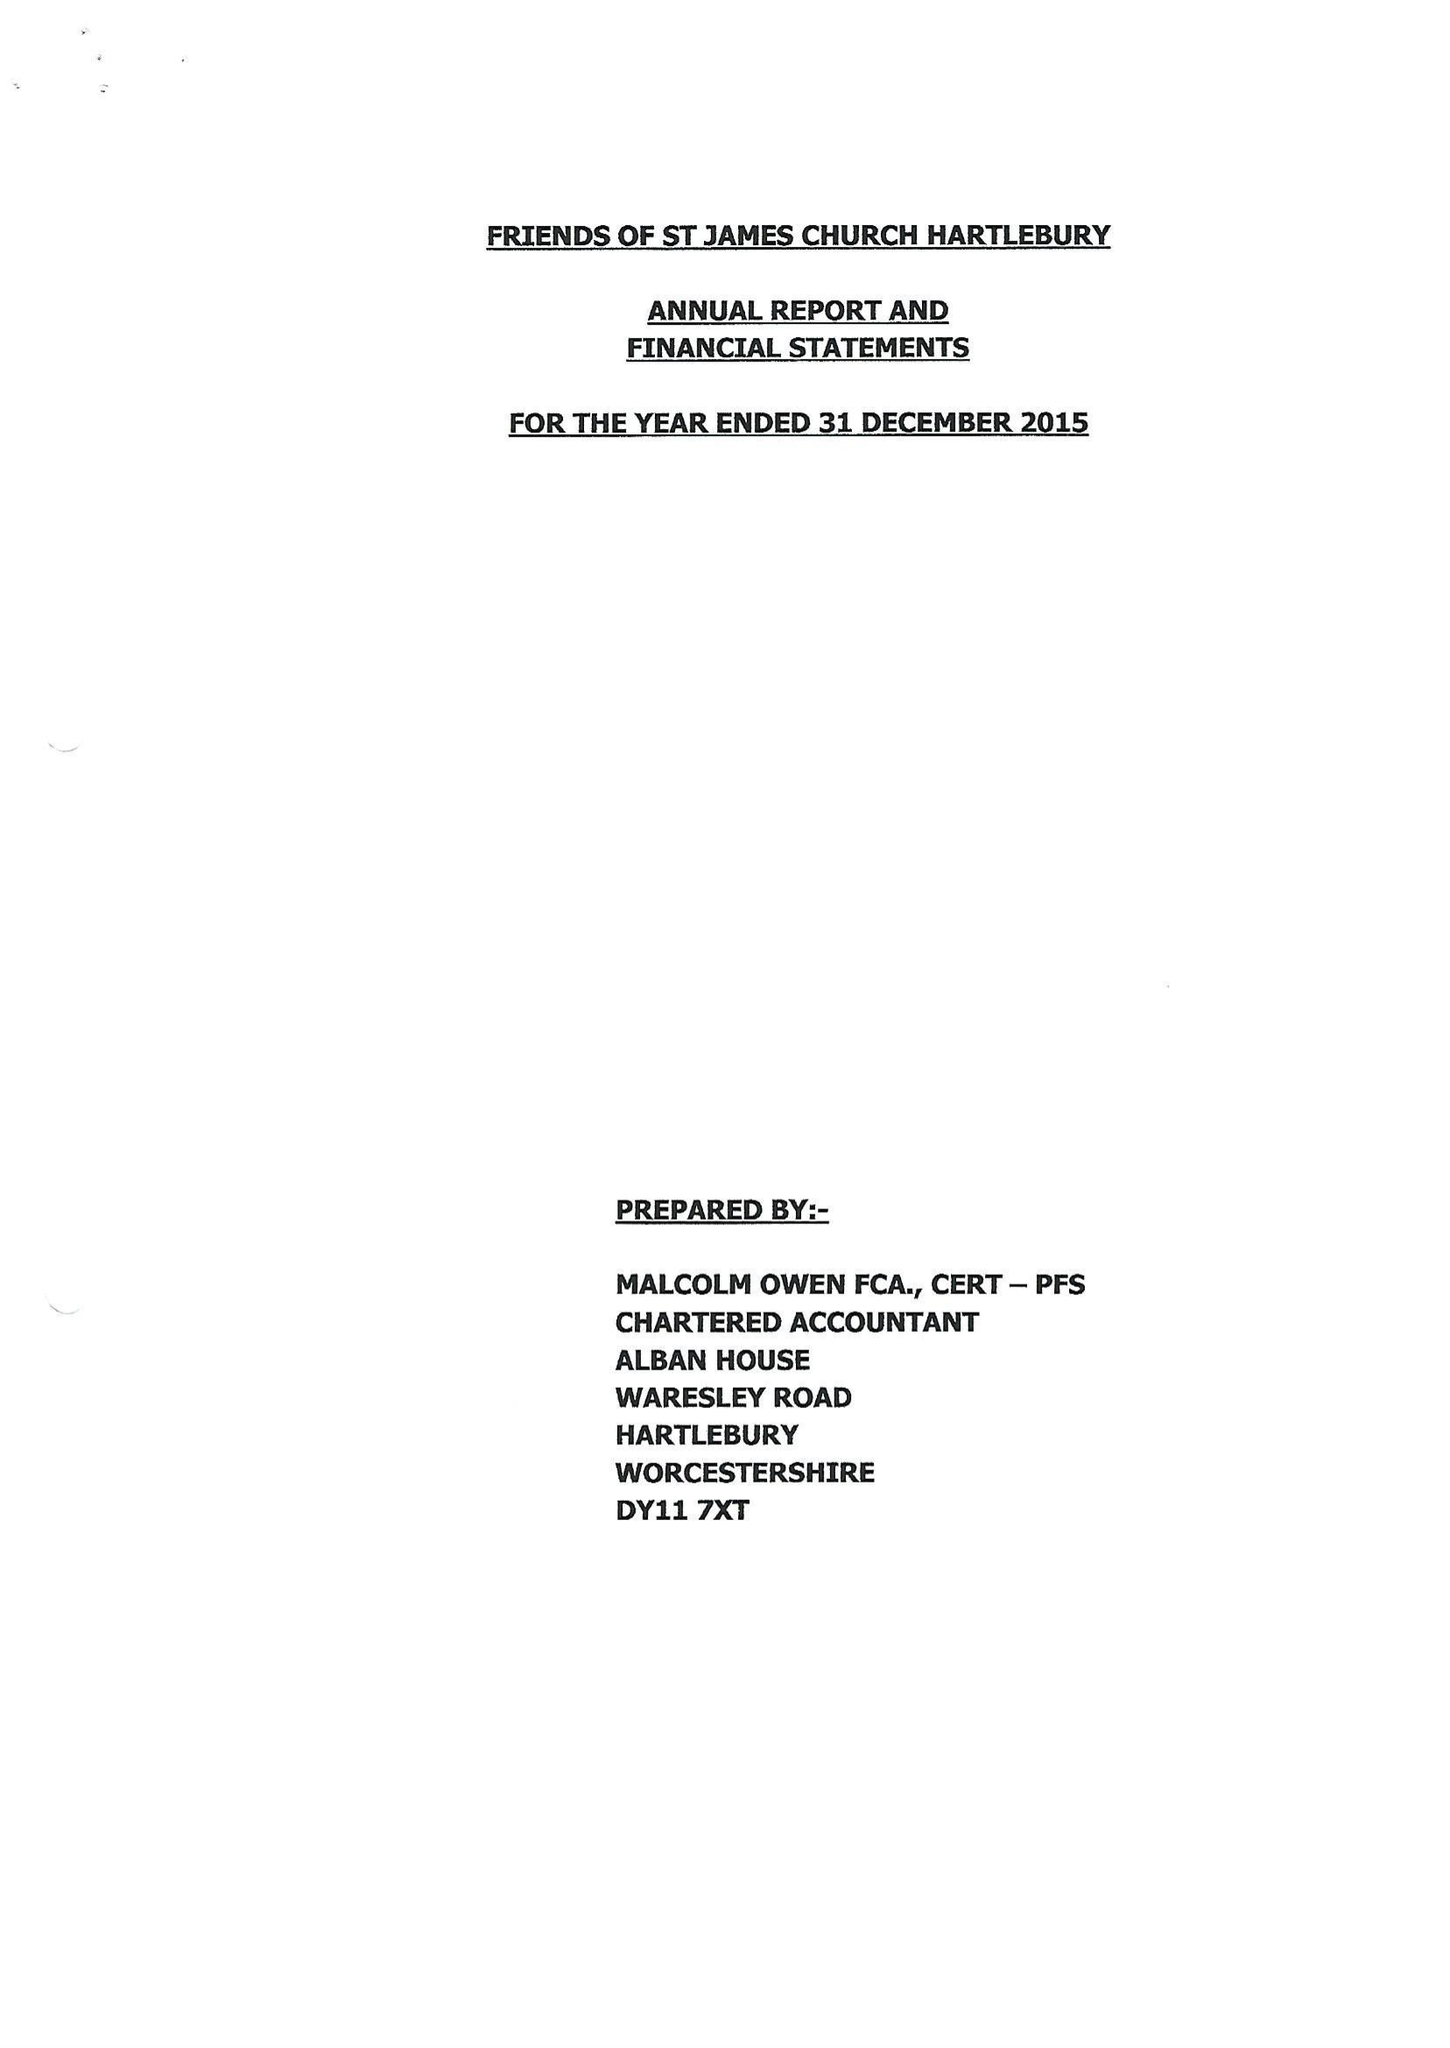What is the value for the address__post_town?
Answer the question using a single word or phrase. KIDDERMINSTER 